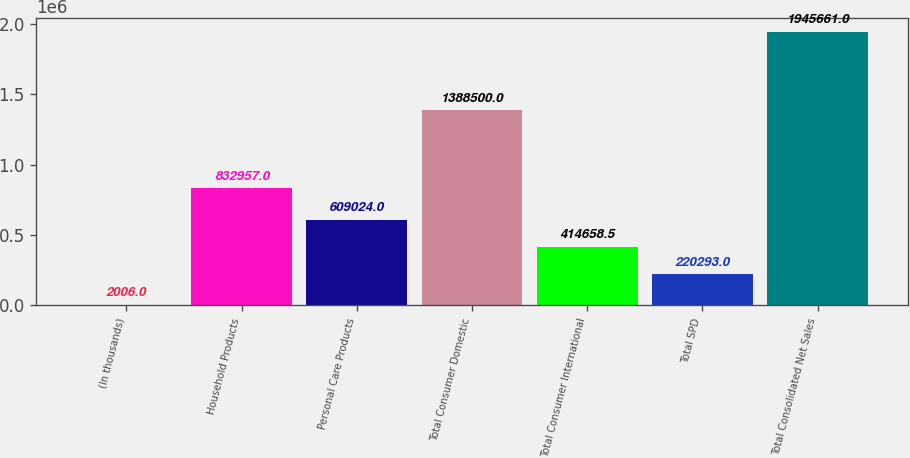<chart> <loc_0><loc_0><loc_500><loc_500><bar_chart><fcel>(In thousands)<fcel>Household Products<fcel>Personal Care Products<fcel>Total Consumer Domestic<fcel>Total Consumer International<fcel>Total SPD<fcel>Total Consolidated Net Sales<nl><fcel>2006<fcel>832957<fcel>609024<fcel>1.3885e+06<fcel>414658<fcel>220293<fcel>1.94566e+06<nl></chart> 